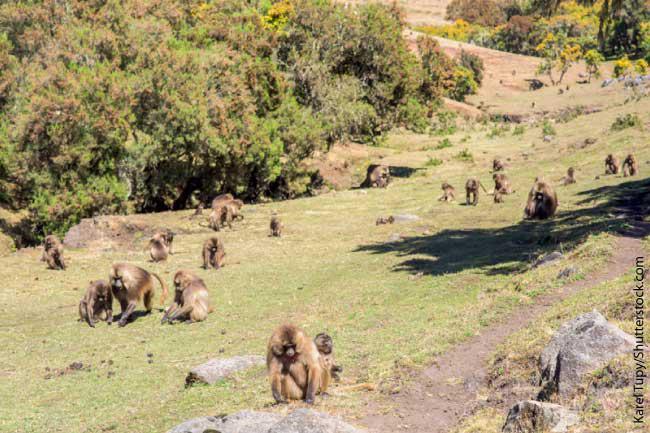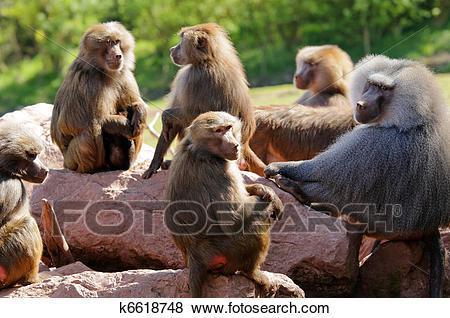The first image is the image on the left, the second image is the image on the right. For the images shown, is this caption "An image shows multiple rear-facing baboons with bulbous pink rears." true? Answer yes or no. No. 